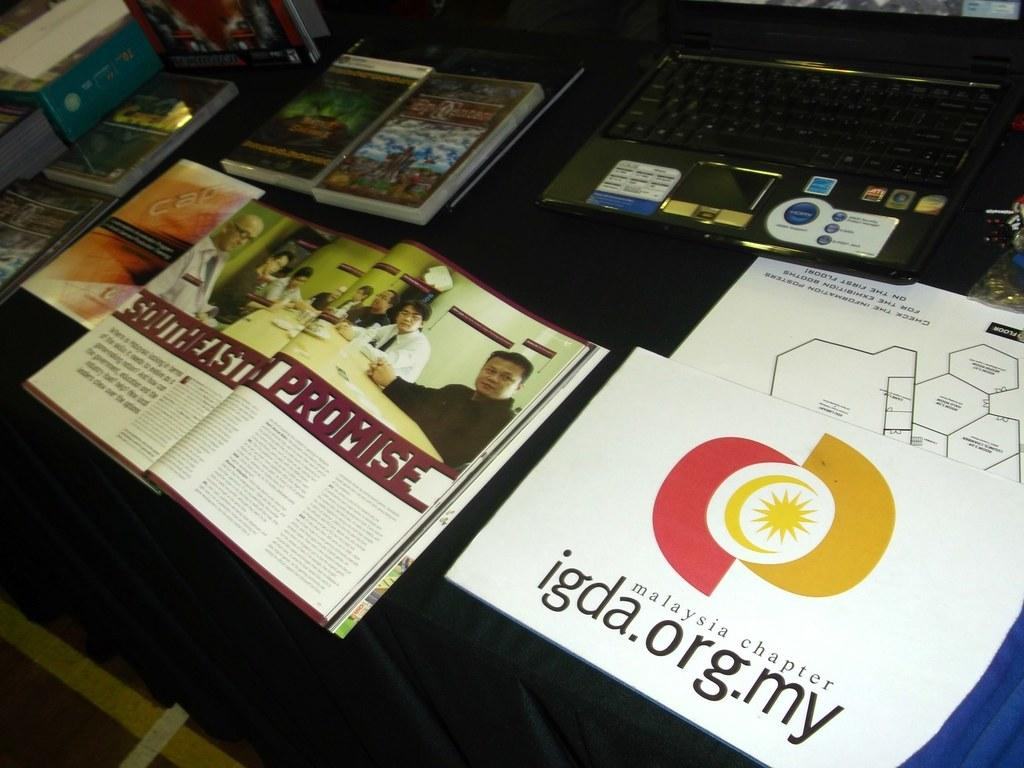<image>
Describe the image concisely. An open magazine with Southeast Promise written across the middle of two pages. 